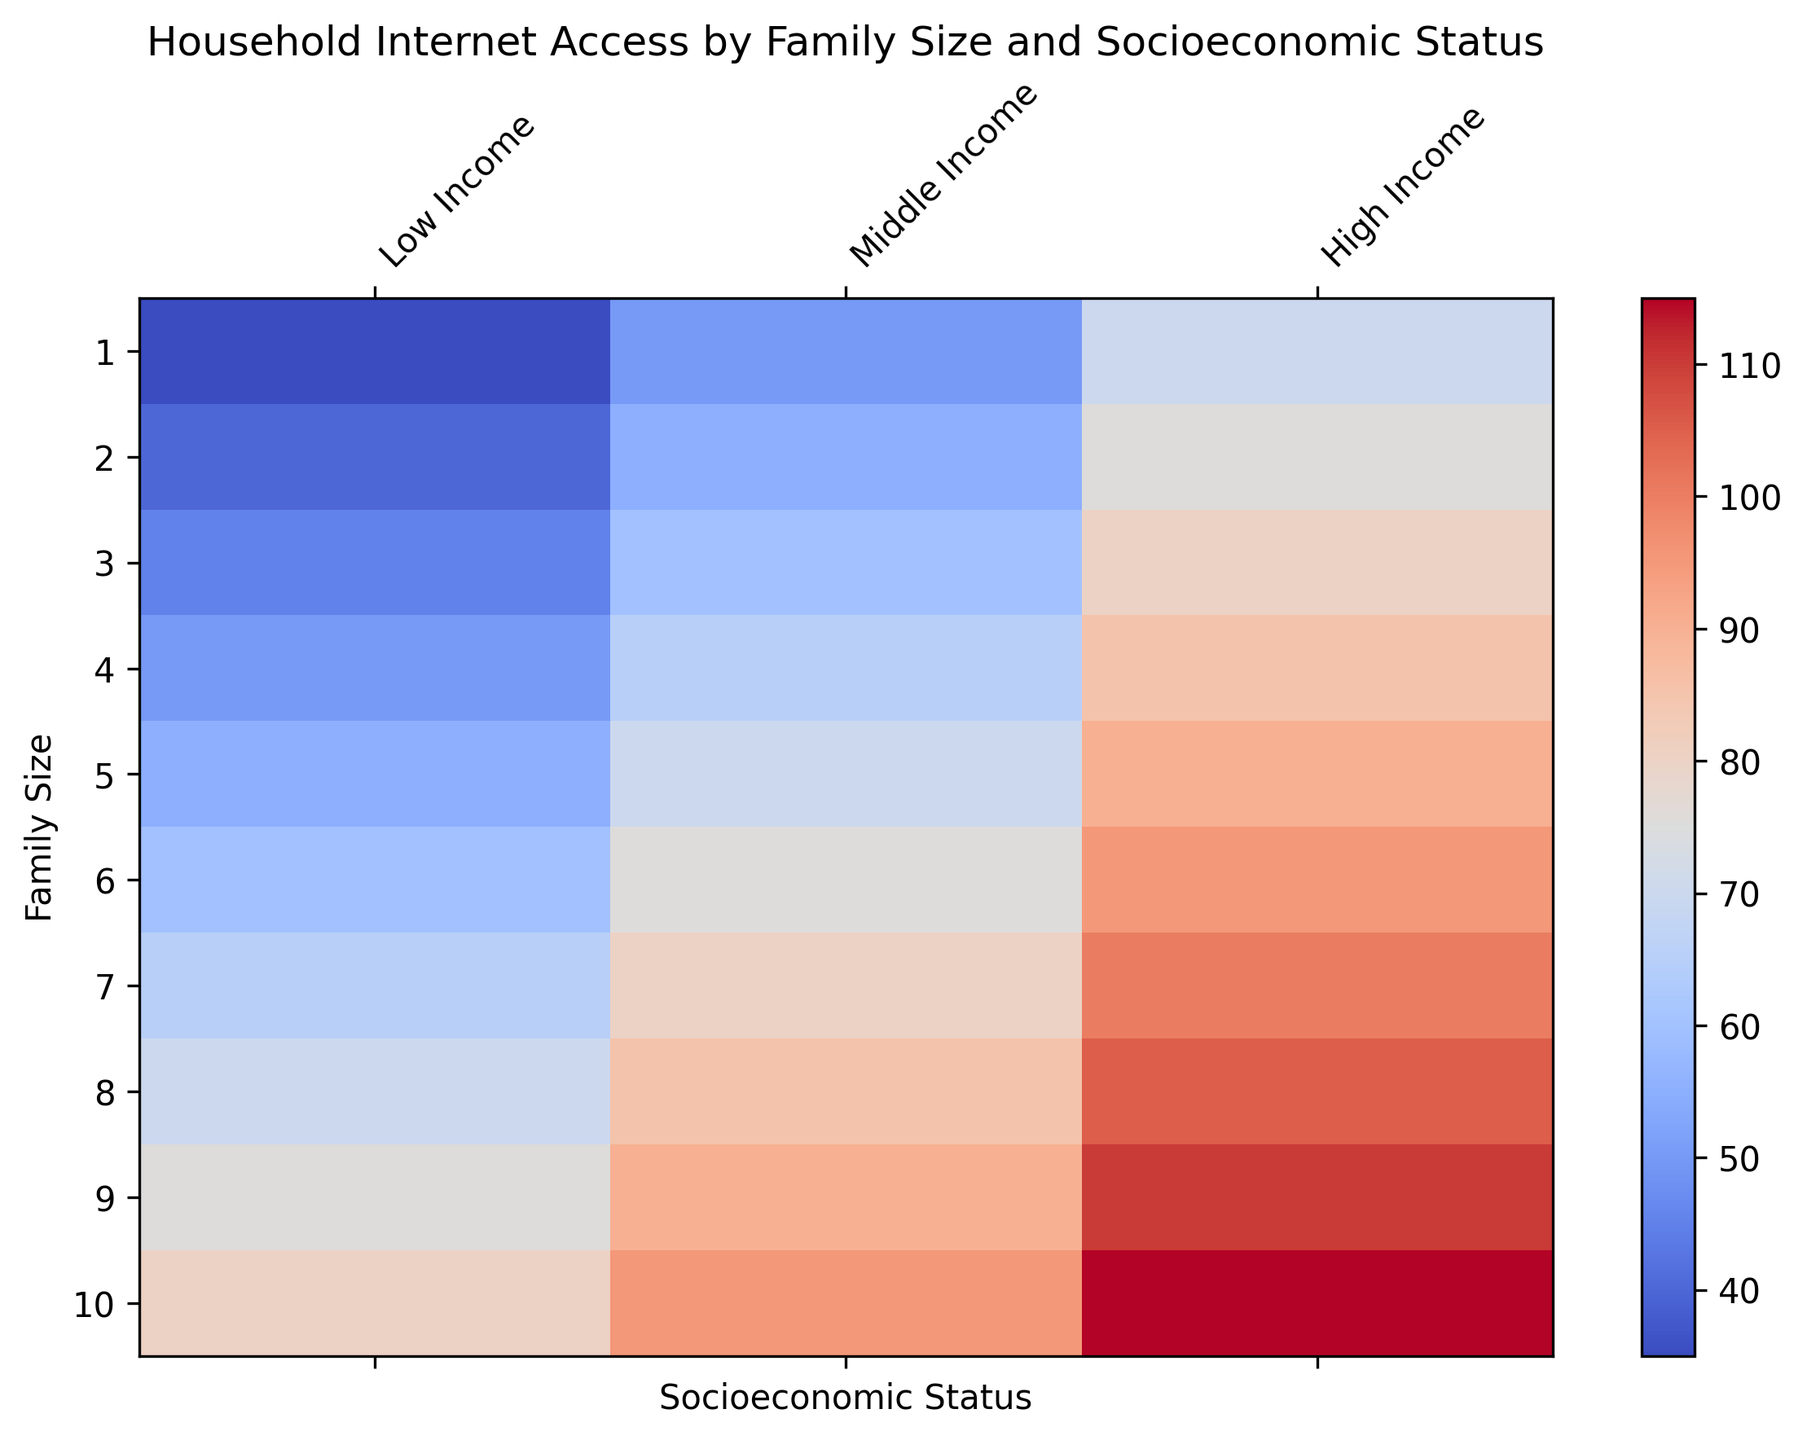Which family size has the highest internet access percentage for high-income households? To find the family size with the highest internet access percentage for high-income households, locate the highest data point in the "High Income" column. The value is 115, which corresponds to the family size of 10.
Answer: 10 Which income group has the least internet access for families of size 3? To determine which income group has the least internet access for families of size 3, compare the values for family size 3. The values are: Low Income (45), Middle Income (60), High Income (80). The smallest value is 45.
Answer: Low Income For family sizes 5 and 6, what is the difference in internet access percentage for middle-income households? To find the difference in internet access percentage for family sizes 5 and 6 in middle-income households, subtract the value for size 5 from size 6. The values are: 75 (size 6) and 70 (size 5), so the difference is 75 - 70 = 5.
Answer: 5 Which family size and income group combination has the lowest internet access percentage? To determine the family size and income group combination with the lowest internet access percentage, identify the smallest value in the heatmap. The lowest value is 35, corresponding to family size 1 and Low Income group.
Answer: Family size 1, Low Income What is the average internet access percentage for middle-income families of sizes 1 through 5? To compute the average internet access percentage for middle-income families of sizes 1 through 5, sum the values and divide by the number of data points. The values are: 50, 55, 60, 65, 70. The sum is 50 + 55 + 60 + 65 + 70 = 300, and the average is 300 / 5 = 60.
Answer: 60 How does internet access percentage change as family size increases from 4 to 7 for high-income households? To describe the change in internet access percentage from family size 4 to 7 for high-income households, observe the values: 85, 90, 95, 100. The trend shows an increase: 85 -> 90 -> 95 -> 100. Each step up in family size corresponds with increased internet access.
Answer: Increases Compare the internet access percentage for low-income families of size 2 and high-income families of size 2. To compare these two data points, look at the values: Low Income (40) and High Income (75). The internet access percentage is higher for high-income families of size 2.
Answer: High Income families have higher access What is the range of internet access percentages for families of size 10 across all income groups? To determine the range of internet access percentages for families of size 10, subtract the minimum value from the maximum value among all income groups. The values are: 80 (Low Income), 95 (Middle Income), 115 (High Income). The range is 115 - 80 = 35.
Answer: 35 Which income group shows the greatest increase in internet access percentage from family size 1 to 10? To find which income group shows the greatest increase, calculate the difference between the values for size 1 and 10 in each group. Low Income: 80 - 35 = 45, Middle Income: 95 - 50 = 45, High Income: 115 - 70 = 45. All groups show an increase of 45 units.
Answer: All groups equally Is the internet access percentage for middle-income families of size 6 higher than that for high-income families of size 4? Compare the values: Middle Income for size 6 is 75, High Income for size 4 is 85. Middle-income families of size 6 have lower internet access than high-income families of size 4.
Answer: No 